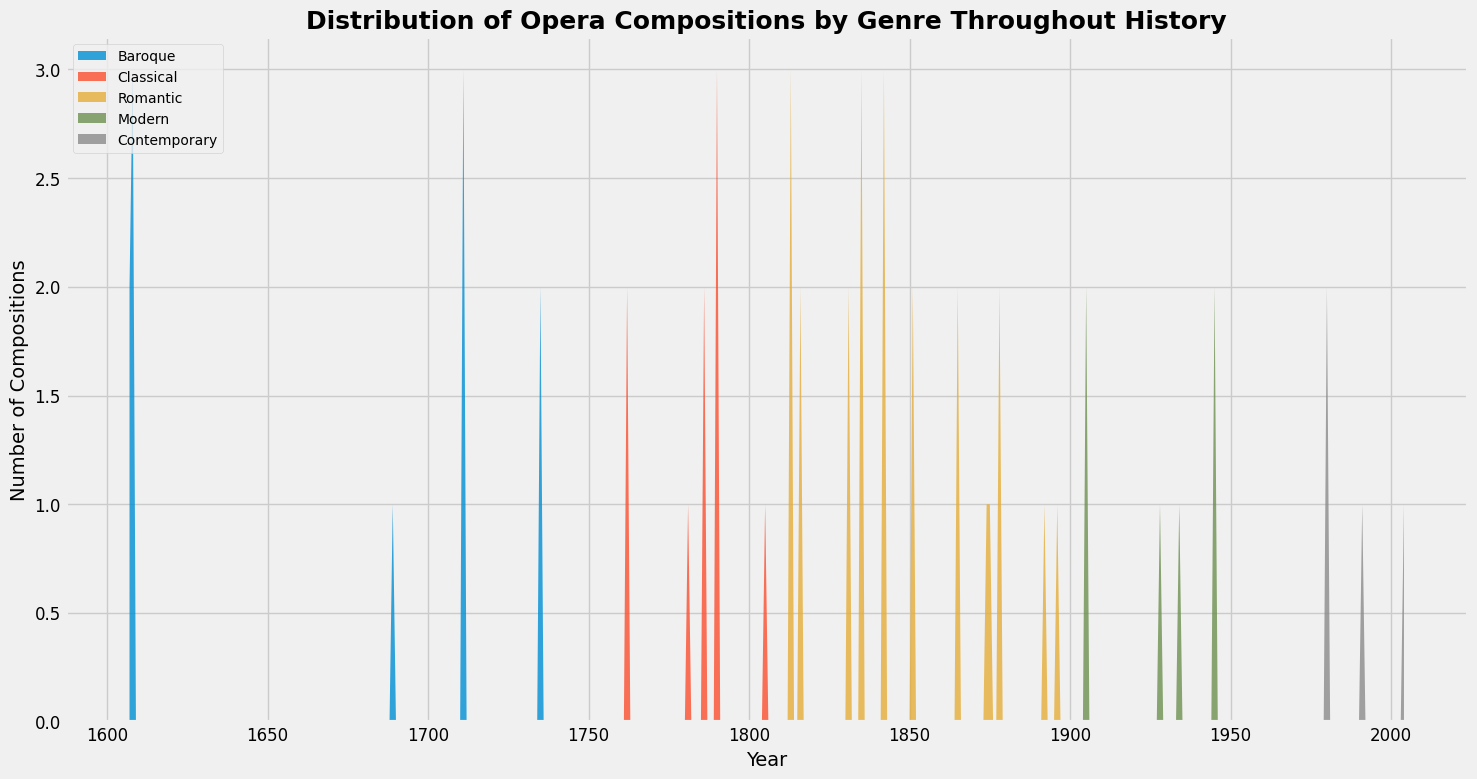Which genre has the highest number of compositions in the mid-1800s (around the 1850s)? Look at the area chart around the 1850s and identify which genre area appears the largest. The Romantic genre has the largest portion in the 1850s.
Answer: Romantic What is the trend in the number of compositions in the Modern genre from 1900 to 2000? Observe the area representing the Modern genre. Notice whether it increases, decreases, or remains stable over the century. The number of compositions in the Modern genre increases from 1900 to 2000.
Answer: Increases Which genre experiences a decline in compositions after 1800? Identify the genre areas that begin to shrink after 1800. The Classical genre shrinks after 1800.
Answer: Classical How does the number of Baroque compositions compare around 1700 and 1750? Compare the height of the Baroque genre area around 1700 and 1750. Around 1700, the Baroque genre area is higher than around 1750, indicating more compositions.
Answer: Higher around 1700 What is the least common genre in the 20th century? Find the genre area that is smallest in the 20th century. The least common genre in the 20th century is Contemporary, as its area is the smallest.
Answer: Contemporary How does the number of Romantic compositions change throughout the 19th century? Observe the area of Romantic compositions from 1800 to 1900. It starts small, peaks in the middle of the century, then decreases towards the end.
Answer: Increases then decreases Compare the total number of compositions in the Baroque and Classical periods. Visually sum the areas under the Baroque and Classical segments. The Baroque period has a larger area, indicating more compositions overall compared to the Classical period.
Answer: Baroque has more Which composer primarily contributed to the rise of the Romantic genre around 1840-1850? Identify the names contributing to the Romantic genre by the rise in area around this period. Giuseppe Verdi contributed significantly.
Answer: Giuseppe Verdi Which genre shows a clear growth trend in compositions from the late 1800s to the early 1900s? Identify the genre area that grows in size between 1880 and 1920. The Modern genre shows clear growth during this period.
Answer: Modern Between which years does the Baroque genre have a noticeable decrease in compositions? Look for the period where the Baroque area's size decreases. The Baroque genre decreases noticeably between 1710 and 1750.
Answer: Between 1710 and 1750 